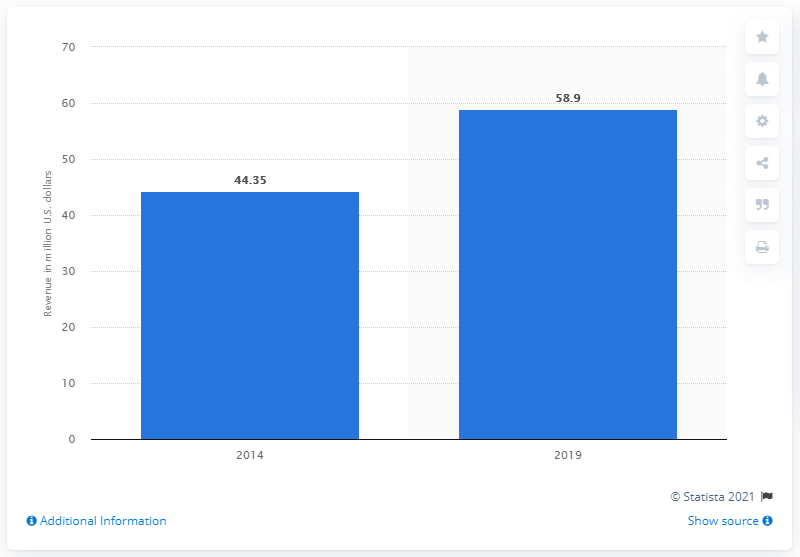Point out several critical features in this image. In 2019, the ACAC Fitness and Wellness Center generated a total revenue of 58.9 million dollars. 